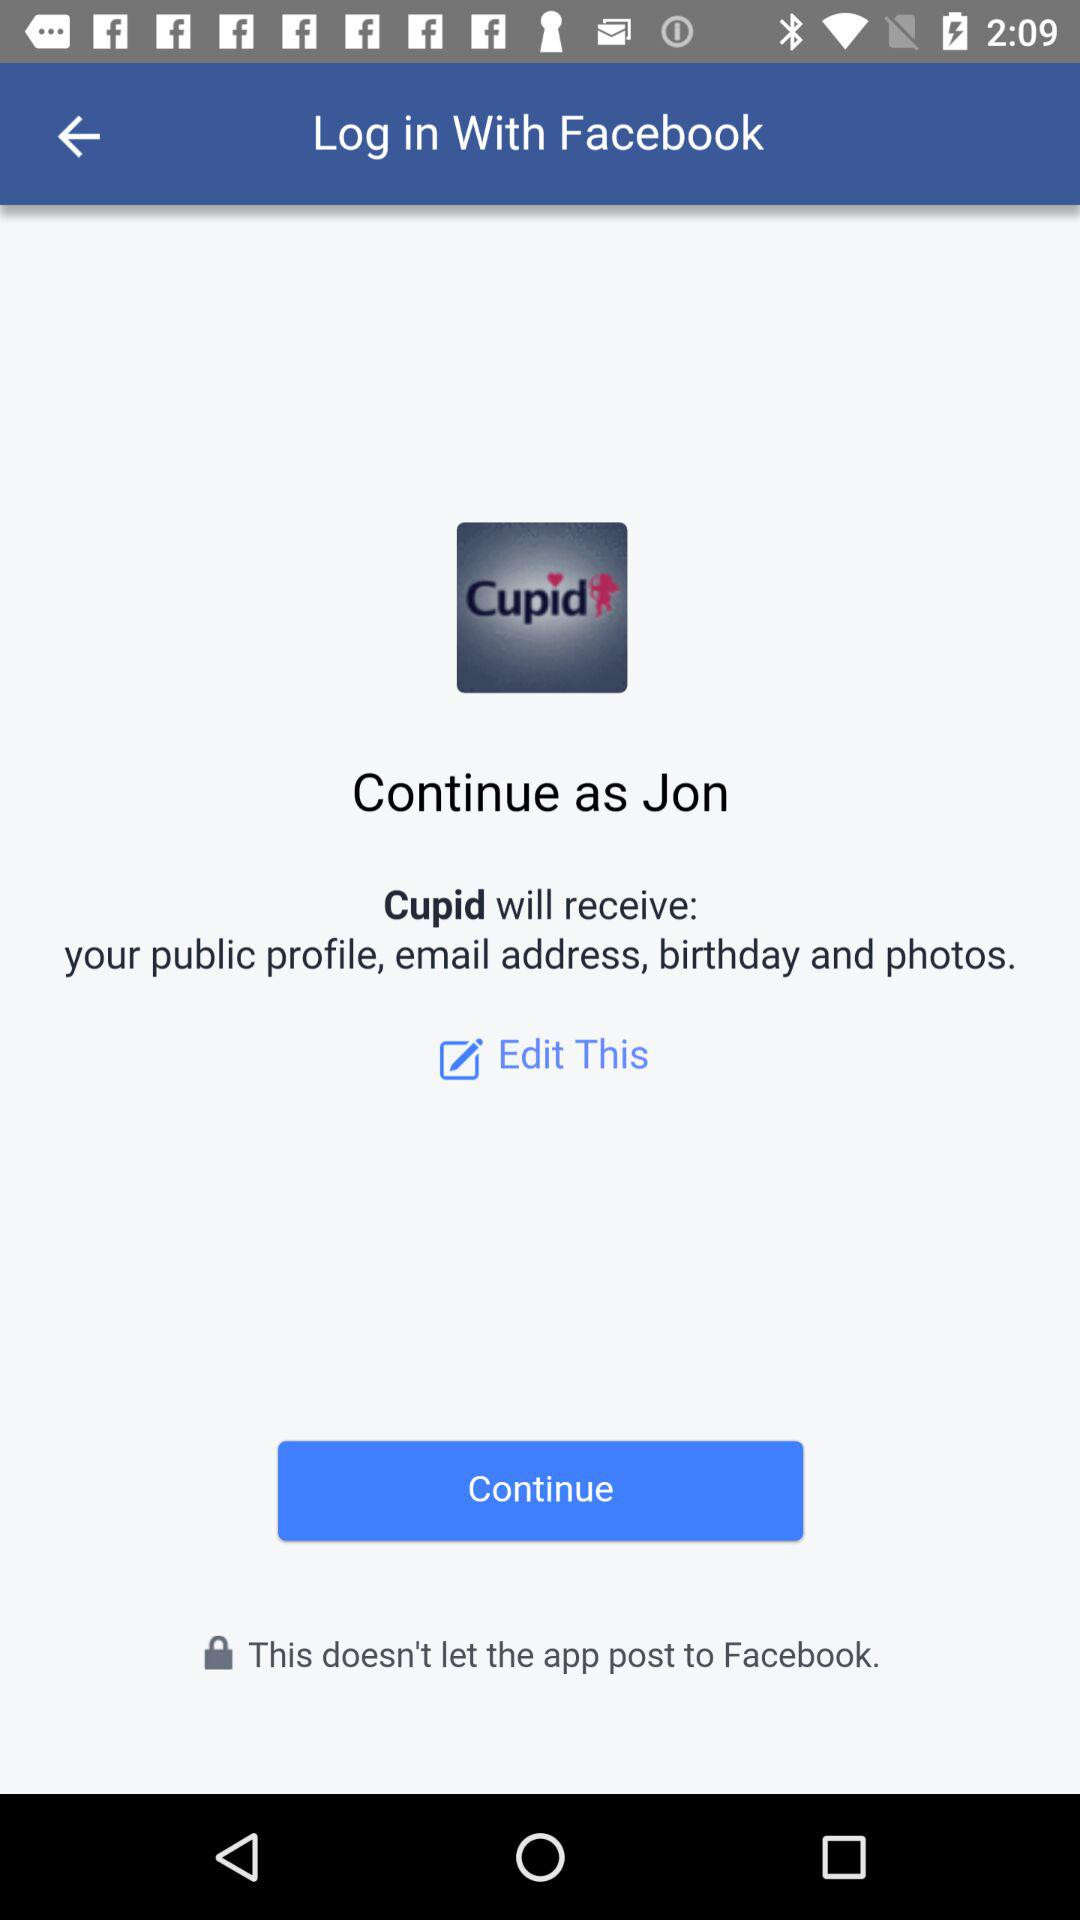What is the user name? The user name is Jon. 